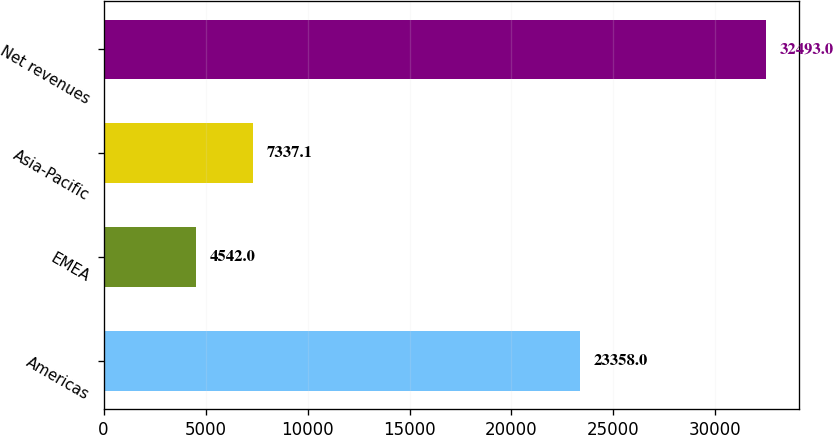Convert chart to OTSL. <chart><loc_0><loc_0><loc_500><loc_500><bar_chart><fcel>Americas<fcel>EMEA<fcel>Asia-Pacific<fcel>Net revenues<nl><fcel>23358<fcel>4542<fcel>7337.1<fcel>32493<nl></chart> 